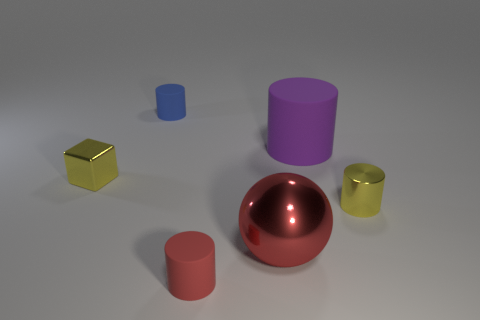The red object that is made of the same material as the purple cylinder is what shape?
Make the answer very short. Cylinder. How many red rubber things have the same shape as the big metallic object?
Keep it short and to the point. 0. There is a small yellow metallic thing right of the red rubber thing; is it the same shape as the thing in front of the large red metallic ball?
Your answer should be compact. Yes. How many things are red cylinders or rubber objects behind the tiny yellow cylinder?
Offer a terse response. 3. What shape is the small metal thing that is the same color as the tiny cube?
Your answer should be very brief. Cylinder. How many purple objects are the same size as the metal sphere?
Your response must be concise. 1. How many yellow things are either matte things or small blocks?
Keep it short and to the point. 1. The big thing in front of the yellow metallic thing right of the red rubber cylinder is what shape?
Your answer should be compact. Sphere. What is the shape of the red thing that is the same size as the purple rubber cylinder?
Give a very brief answer. Sphere. Is there a matte object that has the same color as the ball?
Provide a short and direct response. Yes. 